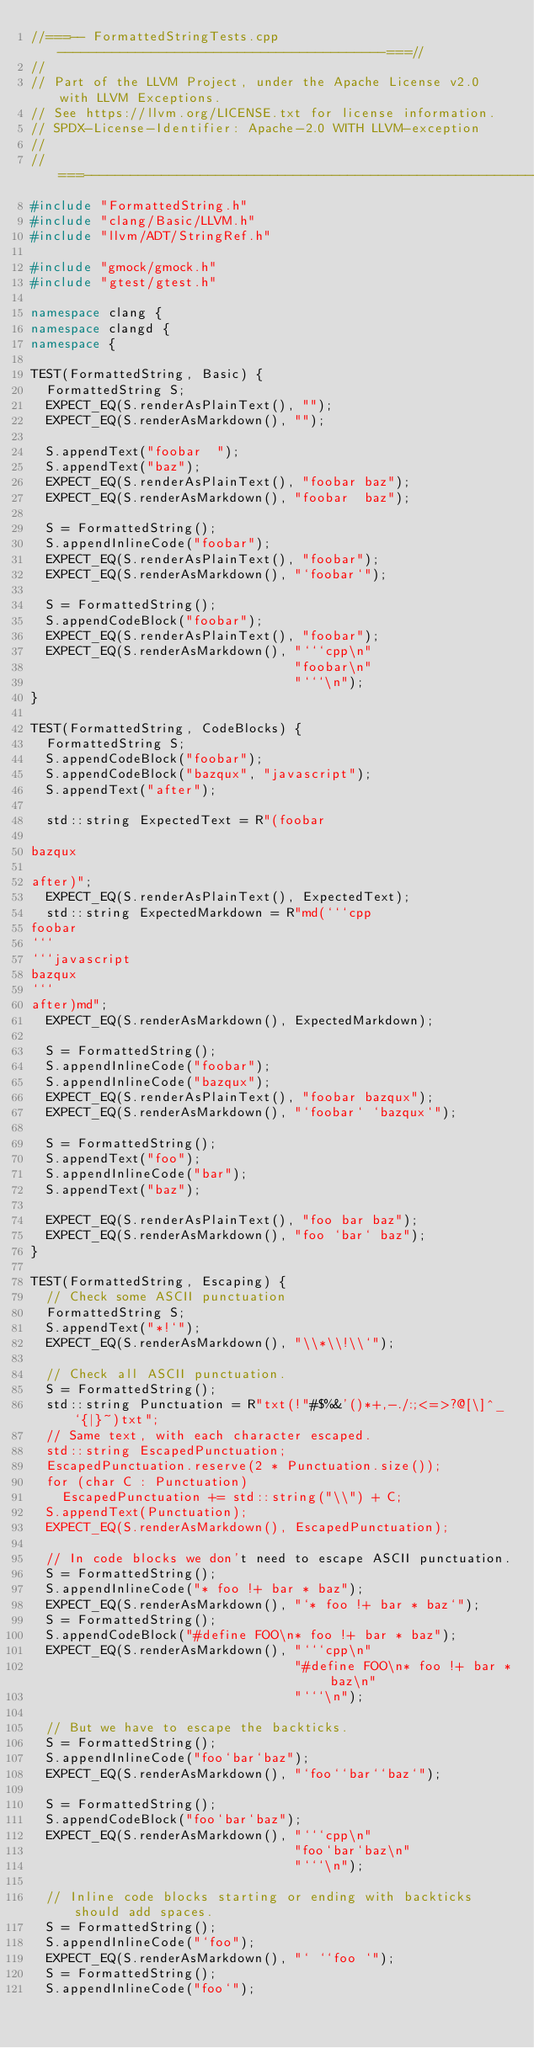Convert code to text. <code><loc_0><loc_0><loc_500><loc_500><_C++_>//===-- FormattedStringTests.cpp ------------------------------------------===//
//
// Part of the LLVM Project, under the Apache License v2.0 with LLVM Exceptions.
// See https://llvm.org/LICENSE.txt for license information.
// SPDX-License-Identifier: Apache-2.0 WITH LLVM-exception
//
//===----------------------------------------------------------------------===//
#include "FormattedString.h"
#include "clang/Basic/LLVM.h"
#include "llvm/ADT/StringRef.h"

#include "gmock/gmock.h"
#include "gtest/gtest.h"

namespace clang {
namespace clangd {
namespace {

TEST(FormattedString, Basic) {
  FormattedString S;
  EXPECT_EQ(S.renderAsPlainText(), "");
  EXPECT_EQ(S.renderAsMarkdown(), "");

  S.appendText("foobar  ");
  S.appendText("baz");
  EXPECT_EQ(S.renderAsPlainText(), "foobar baz");
  EXPECT_EQ(S.renderAsMarkdown(), "foobar  baz");

  S = FormattedString();
  S.appendInlineCode("foobar");
  EXPECT_EQ(S.renderAsPlainText(), "foobar");
  EXPECT_EQ(S.renderAsMarkdown(), "`foobar`");

  S = FormattedString();
  S.appendCodeBlock("foobar");
  EXPECT_EQ(S.renderAsPlainText(), "foobar");
  EXPECT_EQ(S.renderAsMarkdown(), "```cpp\n"
                                  "foobar\n"
                                  "```\n");
}

TEST(FormattedString, CodeBlocks) {
  FormattedString S;
  S.appendCodeBlock("foobar");
  S.appendCodeBlock("bazqux", "javascript");
  S.appendText("after");

  std::string ExpectedText = R"(foobar

bazqux

after)";
  EXPECT_EQ(S.renderAsPlainText(), ExpectedText);
  std::string ExpectedMarkdown = R"md(```cpp
foobar
```
```javascript
bazqux
```
after)md";
  EXPECT_EQ(S.renderAsMarkdown(), ExpectedMarkdown);

  S = FormattedString();
  S.appendInlineCode("foobar");
  S.appendInlineCode("bazqux");
  EXPECT_EQ(S.renderAsPlainText(), "foobar bazqux");
  EXPECT_EQ(S.renderAsMarkdown(), "`foobar` `bazqux`");

  S = FormattedString();
  S.appendText("foo");
  S.appendInlineCode("bar");
  S.appendText("baz");

  EXPECT_EQ(S.renderAsPlainText(), "foo bar baz");
  EXPECT_EQ(S.renderAsMarkdown(), "foo `bar` baz");
}

TEST(FormattedString, Escaping) {
  // Check some ASCII punctuation
  FormattedString S;
  S.appendText("*!`");
  EXPECT_EQ(S.renderAsMarkdown(), "\\*\\!\\`");

  // Check all ASCII punctuation.
  S = FormattedString();
  std::string Punctuation = R"txt(!"#$%&'()*+,-./:;<=>?@[\]^_`{|}~)txt";
  // Same text, with each character escaped.
  std::string EscapedPunctuation;
  EscapedPunctuation.reserve(2 * Punctuation.size());
  for (char C : Punctuation)
    EscapedPunctuation += std::string("\\") + C;
  S.appendText(Punctuation);
  EXPECT_EQ(S.renderAsMarkdown(), EscapedPunctuation);

  // In code blocks we don't need to escape ASCII punctuation.
  S = FormattedString();
  S.appendInlineCode("* foo !+ bar * baz");
  EXPECT_EQ(S.renderAsMarkdown(), "`* foo !+ bar * baz`");
  S = FormattedString();
  S.appendCodeBlock("#define FOO\n* foo !+ bar * baz");
  EXPECT_EQ(S.renderAsMarkdown(), "```cpp\n"
                                  "#define FOO\n* foo !+ bar * baz\n"
                                  "```\n");

  // But we have to escape the backticks.
  S = FormattedString();
  S.appendInlineCode("foo`bar`baz");
  EXPECT_EQ(S.renderAsMarkdown(), "`foo``bar``baz`");

  S = FormattedString();
  S.appendCodeBlock("foo`bar`baz");
  EXPECT_EQ(S.renderAsMarkdown(), "```cpp\n"
                                  "foo`bar`baz\n"
                                  "```\n");

  // Inline code blocks starting or ending with backticks should add spaces.
  S = FormattedString();
  S.appendInlineCode("`foo");
  EXPECT_EQ(S.renderAsMarkdown(), "` ``foo `");
  S = FormattedString();
  S.appendInlineCode("foo`");</code> 